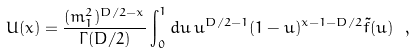<formula> <loc_0><loc_0><loc_500><loc_500>U ( x ) = \frac { ( m _ { 1 } ^ { 2 } ) ^ { D / 2 - x } } { \Gamma ( D / 2 ) } \int _ { 0 } ^ { 1 } d u \, u ^ { D / 2 - 1 } ( 1 - u ) ^ { x - 1 - D / 2 } \tilde { f } ( u ) \ ,</formula> 